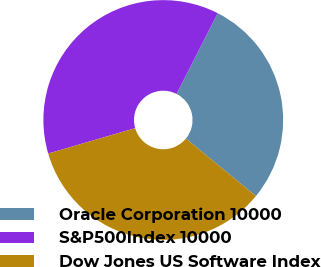<chart> <loc_0><loc_0><loc_500><loc_500><pie_chart><fcel>Oracle Corporation 10000<fcel>S&P500Index 10000<fcel>Dow Jones US Software Index<nl><fcel>28.44%<fcel>37.02%<fcel>34.54%<nl></chart> 